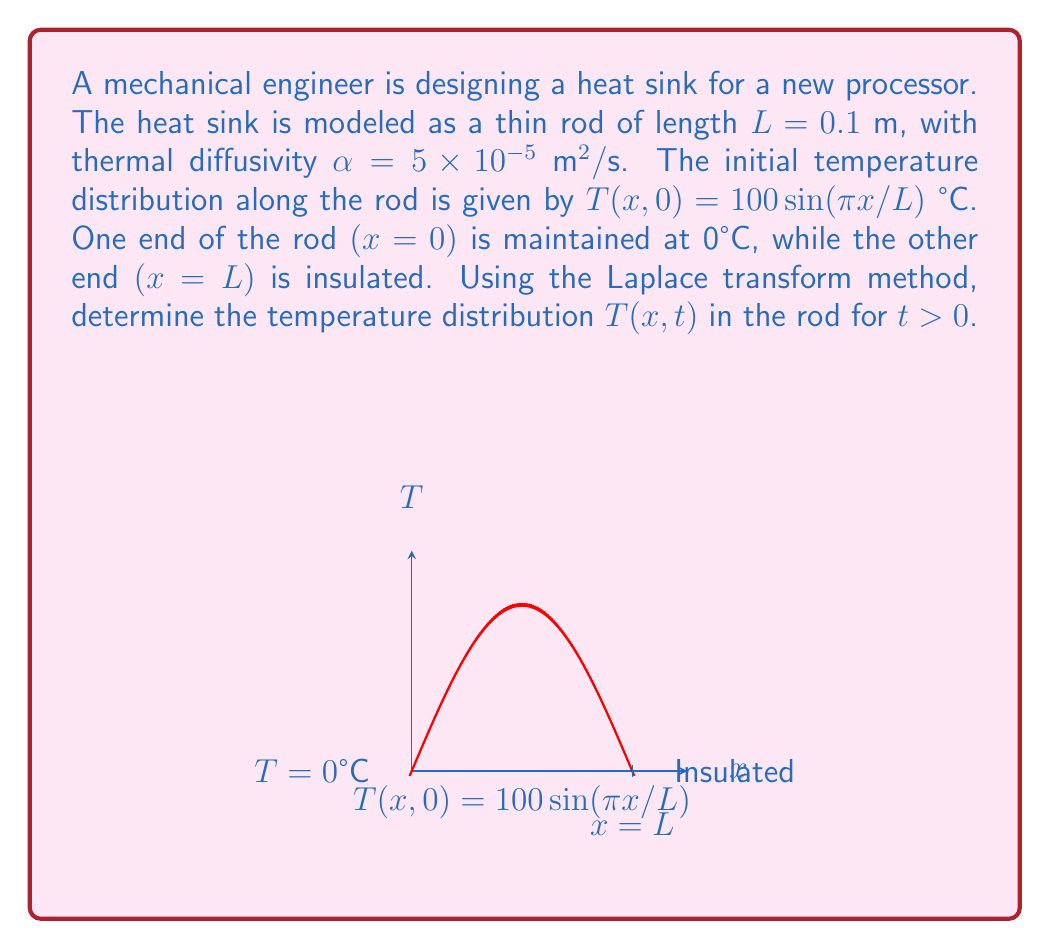Could you help me with this problem? To solve this heat transfer problem using the Laplace transform method, we'll follow these steps:

1) The heat equation for this problem is:
   $$\frac{\partial T}{\partial t} = \alpha \frac{\partial^2 T}{\partial x^2}$$

2) The boundary and initial conditions are:
   T(0,t) = 0
   ∂T/∂x(L,t) = 0
   T(x,0) = 100sin(πx/L)

3) Apply the Laplace transform to the heat equation with respect to t:
   $$s\bar{T}(x,s) - T(x,0) = \alpha \frac{d^2\bar{T}}{dx^2}$$

4) Substitute the initial condition:
   $$s\bar{T}(x,s) - 100\sin(\frac{\pi x}{L}) = \alpha \frac{d^2\bar{T}}{dx^2}$$

5) Rearrange:
   $$\frac{d^2\bar{T}}{dx^2} - \frac{s}{\alpha}\bar{T} = -\frac{100}{\alpha}\sin(\frac{\pi x}{L})$$

6) The general solution to this ODE is:
   $$\bar{T}(x,s) = A\cosh(\sqrt{\frac{s}{\alpha}}x) + B\sinh(\sqrt{\frac{s}{\alpha}}x) + \frac{100}{s + \alpha(\frac{\pi}{L})^2}\sin(\frac{\pi x}{L})$$

7) Apply the Laplace transform of the boundary conditions:
   $\bar{T}(0,s) = 0$ and $\frac{d\bar{T}}{dx}(L,s) = 0$

8) From $\bar{T}(0,s) = 0$, we get A = 0.

9) From $\frac{d\bar{T}}{dx}(L,s) = 0$, we get:
   $$B\sqrt{\frac{s}{\alpha}}\cosh(\sqrt{\frac{s}{\alpha}}L) + \frac{100\pi}{L(s + \alpha(\frac{\pi}{L})^2)}\cos(\pi) = 0$$

10) Solve for B:
    $$B = -\frac{100\pi}{L\sqrt{s\alpha}(s + \alpha(\frac{\pi}{L})^2)}\frac{\cos(\pi)}{\cosh(\sqrt{\frac{s}{\alpha}}L)}$$

11) Substitute A and B back into the general solution:
    $$\bar{T}(x,s) = \frac{100}{s + \alpha(\frac{\pi}{L})^2}\sin(\frac{\pi x}{L}) - \frac{100\pi}{L\sqrt{s\alpha}(s + \alpha(\frac{\pi}{L})^2)}\frac{\cos(\pi)}{\cosh(\sqrt{\frac{s}{\alpha}}L)}\sinh(\sqrt{\frac{s}{\alpha}}x)$$

12) Apply the inverse Laplace transform:
    $$T(x,t) = 100e^{-\alpha(\frac{\pi}{L})^2t}\sin(\frac{\pi x}{L}) + 100\sum_{n=1}^{\infty}\frac{2(-1)^{n+1}}{(2n-1)\pi}e^{-\alpha(\frac{(2n-1)\pi}{L})^2t}\sin(\frac{(2n-1)\pi x}{L})$$

This is the final temperature distribution in the rod for t > 0.
Answer: $$T(x,t) = 100e^{-\alpha(\frac{\pi}{L})^2t}\sin(\frac{\pi x}{L}) + 100\sum_{n=1}^{\infty}\frac{2(-1)^{n+1}}{(2n-1)\pi}e^{-\alpha(\frac{(2n-1)\pi}{L})^2t}\sin(\frac{(2n-1)\pi x}{L})$$ 